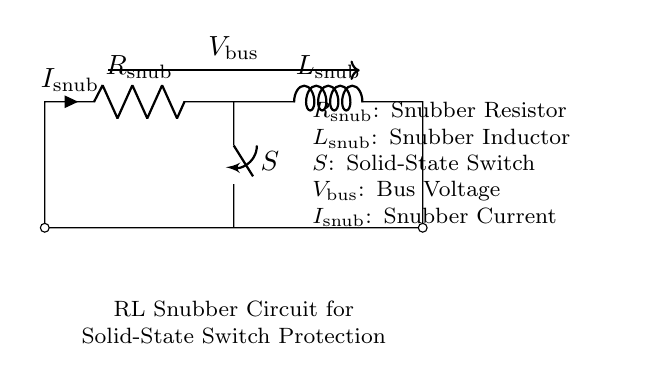What components are present in the snubber circuit? The components in the circuit are a resistor, an inductor, and a solid-state switch as indicated by their labels in the diagram.
Answer: resistor, inductor, solid-state switch What is the function of the resistor in the circuit? The resistor, labeled R_snub, limits the current flowing through the snubber circuit, thus protecting the solid-state switch from voltage spikes.
Answer: limit current What type of circuit is this? This circuit is an RL snubber circuit designed to protect solid-state switches from voltage transients during operation.
Answer: RL snubber circuit What is the label for the current flowing through the snubber circuit? The current flowing through the circuit is indicated by the label I_snub in the diagram, which represents the snubber current.
Answer: I_snub How does the inductor contribute to the circuit's function? The inductor, labeled L_snub, stores energy when current flows through it, which helps absorb and dissipate abrupt voltage changes, thus protecting the switch.
Answer: absorb voltage changes What is the purpose of a snubber circuit? The primary purpose of a snubber circuit is to protect solid-state switches from voltage spikes or transients that can occur during switching operations.
Answer: protect switches from transients What is represented by V_bus in the diagram? V_bus represents the bus voltage that supplies power to the circuit and is indicated above the components in the diagram.
Answer: bus voltage 